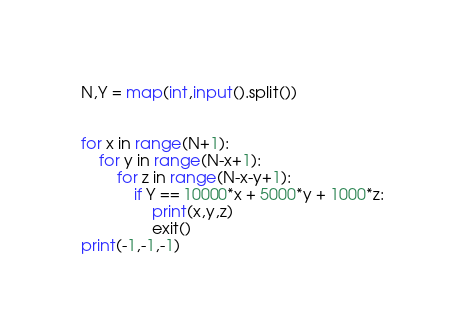Convert code to text. <code><loc_0><loc_0><loc_500><loc_500><_Python_>N,Y = map(int,input().split())


for x in range(N+1):
	for y in range(N-x+1):
		for z in range(N-x-y+1):
			if Y == 10000*x + 5000*y + 1000*z:
				print(x,y,z)
				exit()
print(-1,-1,-1)</code> 